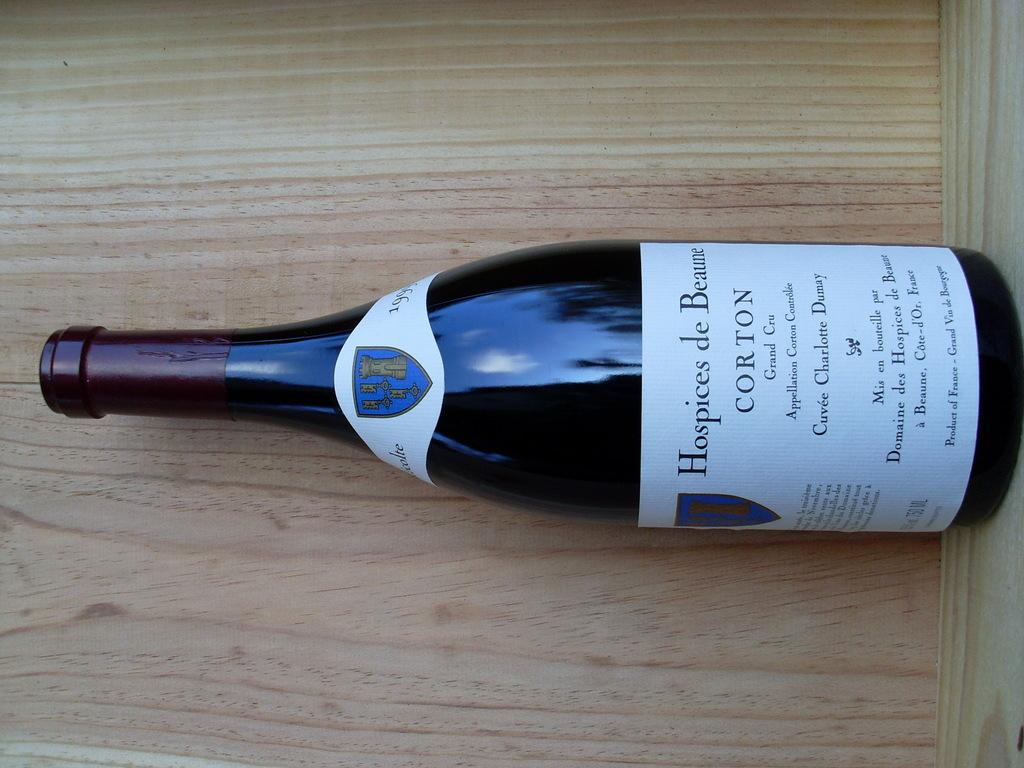<image>
Relay a brief, clear account of the picture shown. The bottle of wine is made in Beaune France and should be stored properly. 